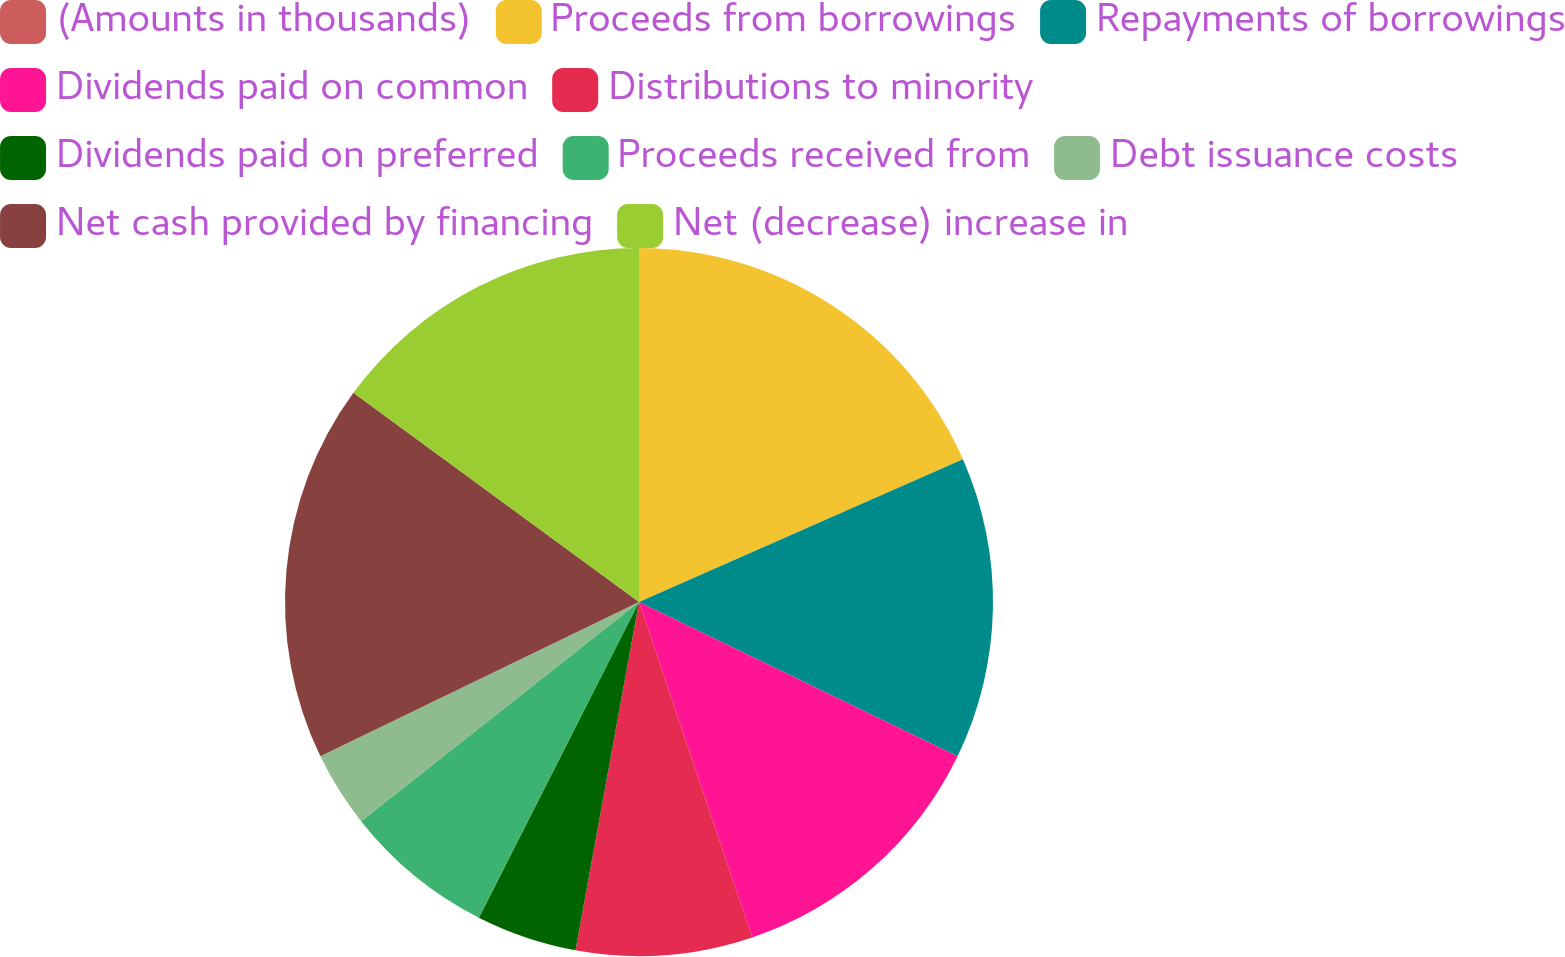Convert chart to OTSL. <chart><loc_0><loc_0><loc_500><loc_500><pie_chart><fcel>(Amounts in thousands)<fcel>Proceeds from borrowings<fcel>Repayments of borrowings<fcel>Dividends paid on common<fcel>Distributions to minority<fcel>Dividends paid on preferred<fcel>Proceeds received from<fcel>Debt issuance costs<fcel>Net cash provided by financing<fcel>Net (decrease) increase in<nl><fcel>0.0%<fcel>18.39%<fcel>13.79%<fcel>12.64%<fcel>8.05%<fcel>4.6%<fcel>6.9%<fcel>3.45%<fcel>17.24%<fcel>14.94%<nl></chart> 